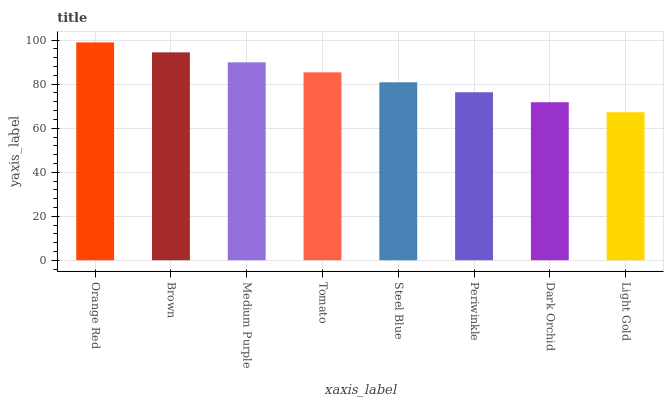Is Light Gold the minimum?
Answer yes or no. Yes. Is Orange Red the maximum?
Answer yes or no. Yes. Is Brown the minimum?
Answer yes or no. No. Is Brown the maximum?
Answer yes or no. No. Is Orange Red greater than Brown?
Answer yes or no. Yes. Is Brown less than Orange Red?
Answer yes or no. Yes. Is Brown greater than Orange Red?
Answer yes or no. No. Is Orange Red less than Brown?
Answer yes or no. No. Is Tomato the high median?
Answer yes or no. Yes. Is Steel Blue the low median?
Answer yes or no. Yes. Is Steel Blue the high median?
Answer yes or no. No. Is Dark Orchid the low median?
Answer yes or no. No. 